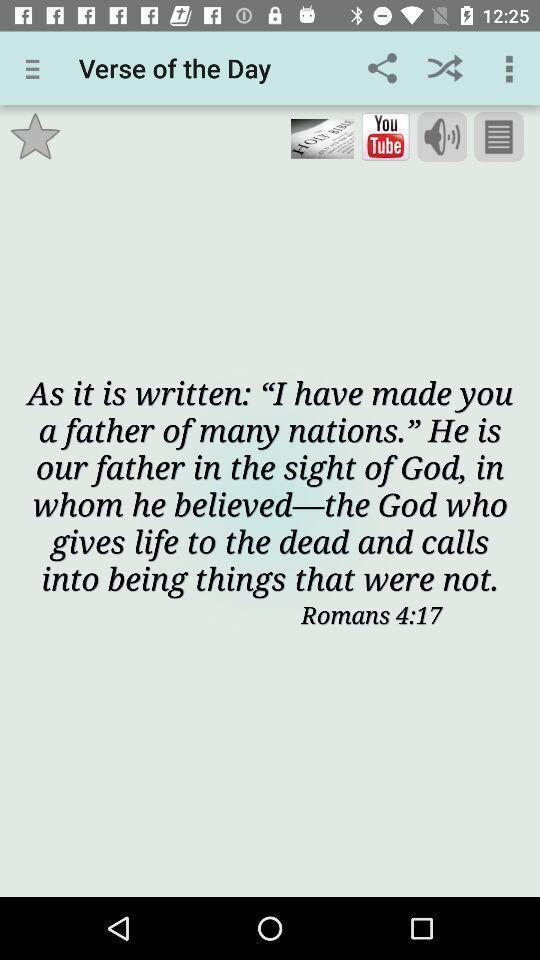Please provide a description for this image. Verse page of a holy app. 